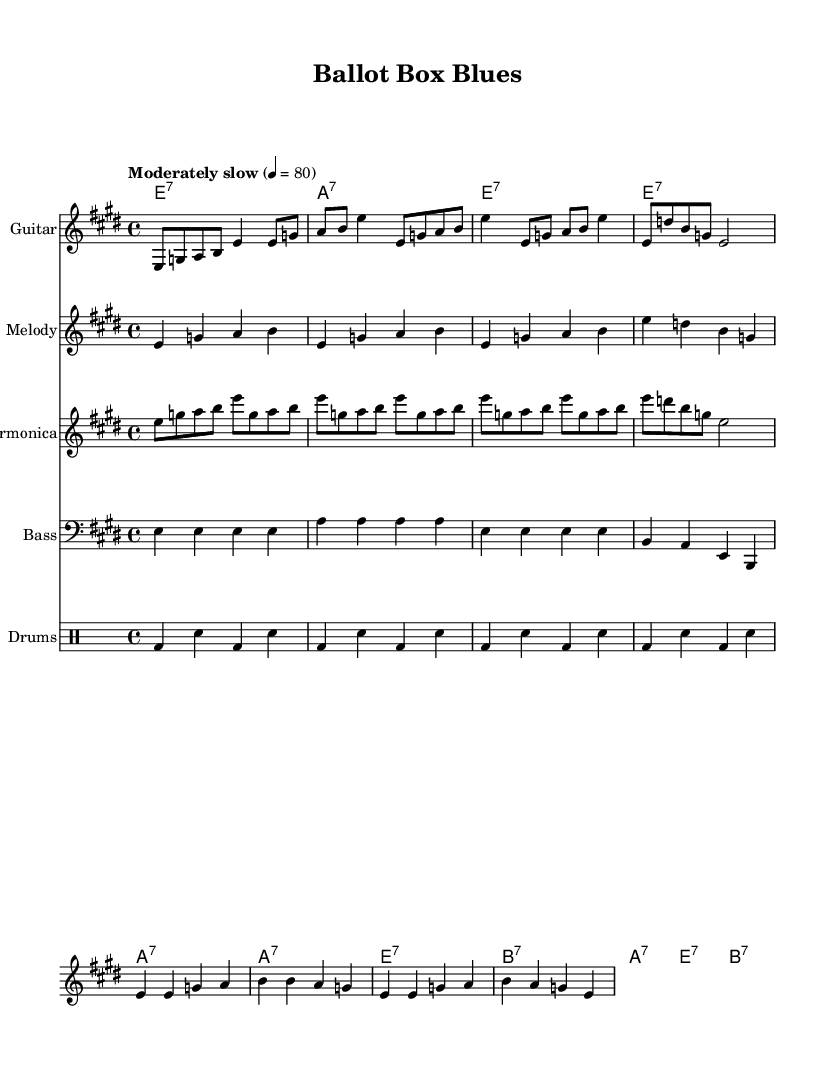What is the key signature of this music? The key signature is E major, which has four sharps (F#, C#, G#, D#). This can be identified from the key signature at the beginning of the music.
Answer: E major What is the time signature of this music? The time signature is 4/4, indicated at the beginning of the score. This means there are four beats per measure and the quarter note gets one beat.
Answer: 4/4 What is the tempo marking for this piece? The tempo marking is "Moderately slow" at 4 = 80. This indicates the speed at which the music should be played and is specified at the beginning of the score.
Answer: Moderately slow, 80 How many measures are in the verse section? There are four measures in the verse, as the verse lyrics are written to correspond with the melody, which spans four measures in the score.
Answer: 4 What instruments are included in this arrangement? The instruments listed are Guitar, Melody, Harmonica, Bass, and Drums. This can be seen from the Staff names at the beginning of each section in the score.
Answer: Guitar, Melody, Harmonica, Bass, Drums What is the main theme of the chorus lyrics? The main theme of the chorus revolves around the intertwining of fate and ballots during election time, as indicated in the lyrics presented. This is a recurring thematic element in blues music, connecting personal fate with social events.
Answer: Fate and ballots intertwine, Chicago blues, election time 